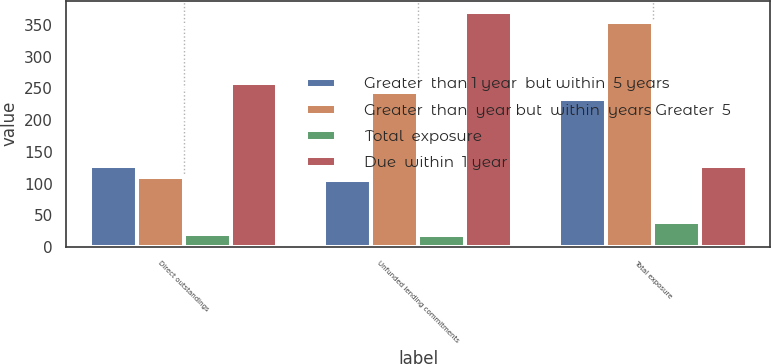Convert chart. <chart><loc_0><loc_0><loc_500><loc_500><stacked_bar_chart><ecel><fcel>Direct outstandings<fcel>Unfunded lending commitments<fcel>Total exposure<nl><fcel>Greater  than 1 year  but within  5 years<fcel>128<fcel>106<fcel>234<nl><fcel>Greater  than  year but  within  years Greater  5<fcel>110<fcel>245<fcel>355<nl><fcel>Total  exposure<fcel>20<fcel>19<fcel>39<nl><fcel>Due  within  1 year<fcel>258<fcel>370<fcel>128<nl></chart> 